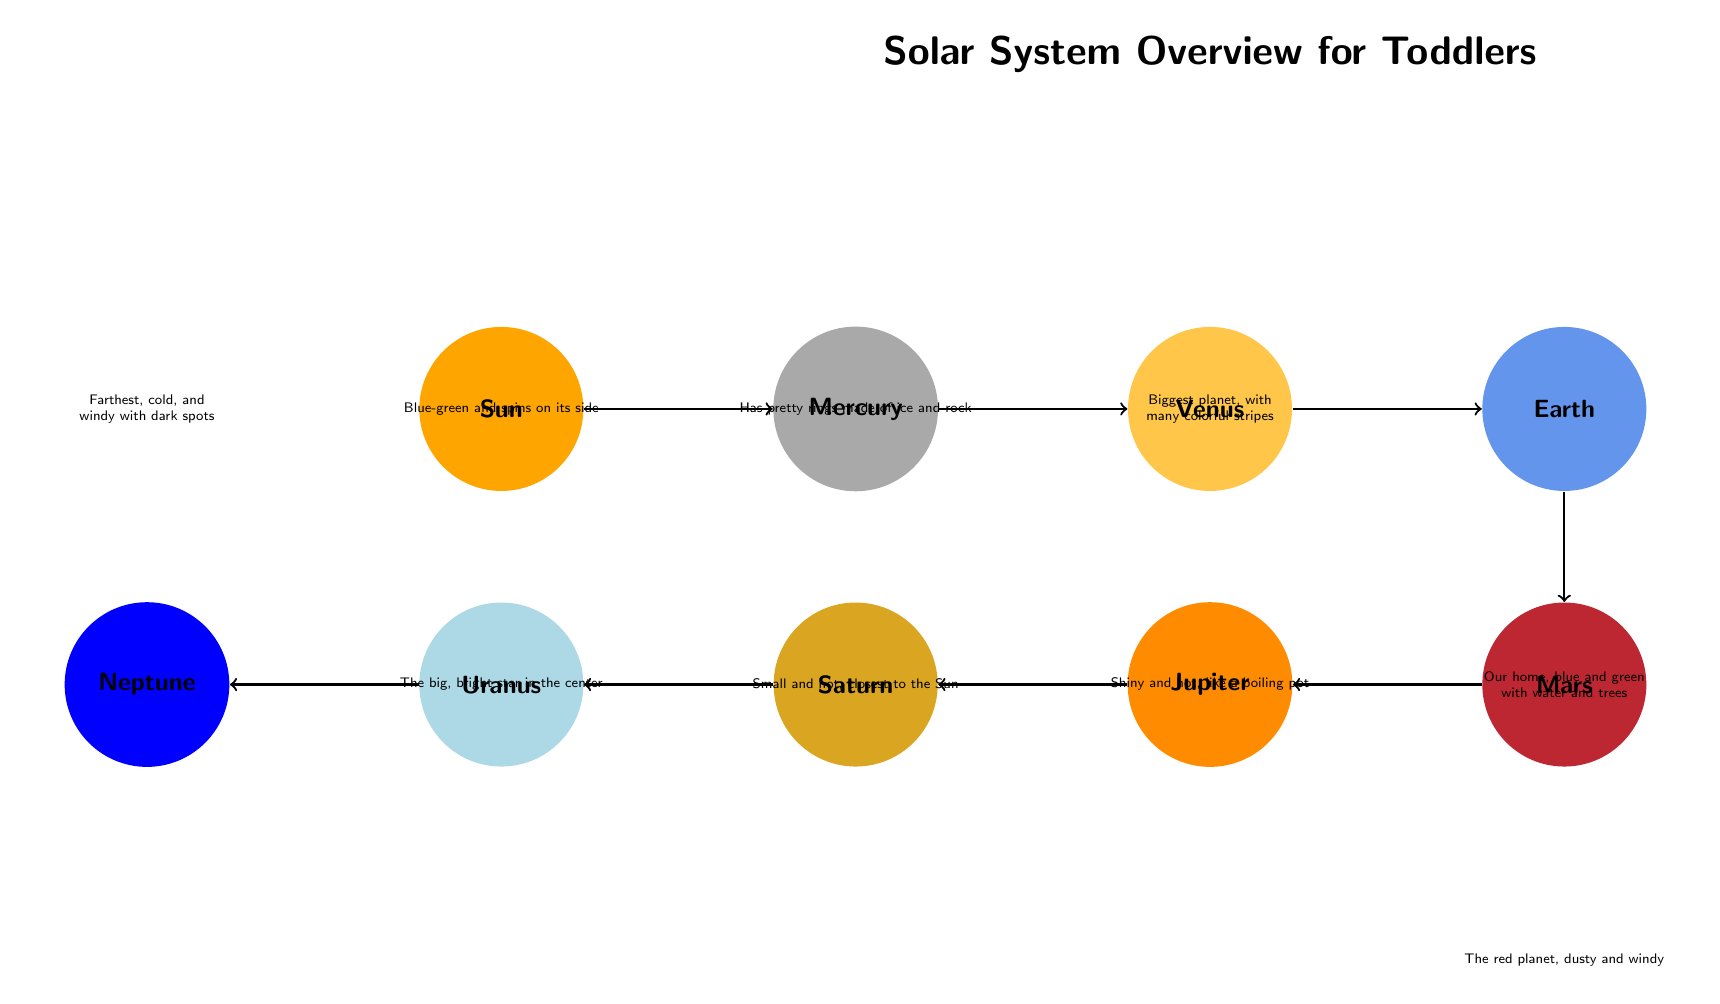What is the brightest object in the solar system? The diagram clearly identifies the Sun as the primary node, labeled prominently at the center. It depicts the Sun as a big, bright star in the center, indicating its significance among celestial bodies.
Answer: Sun Which planet is closest to the Sun? By following the arrows leading right from the Sun, you can track the planets in order. Mercury is the first one reached, marked as small and hot, which confirms its position as the closest planet.
Answer: Mercury What color is Mars depicted as? The diagram shows Mars positioned below Earth and is filled with a specific red color. Additionally, the description directly reinforces that it is the red planet.
Answer: Red How many planets are shown in the diagram? By counting the nodes that represent planets (Mercury, Venus, Earth, Mars, Jupiter, Saturn, Uranus, Neptune), which are distinctly labeled and colored, we conclude there are eight.
Answer: Eight Which planet has rings? Saturn is clearly labeled in the diagram, with a description directly stating it has pretty rings made of ice and rock, distinguishing it from other planets.
Answer: Saturn What is the relationship between Jupiter and Mars? The diagram indicates the flow of connections with arrows. From the description, Mars is mentioned under Earth, while Jupiter is shown to the left of Mars. Hence, Jupiter follows Mars in the arrangement of the planets.
Answer: Jupiter follows Mars What color is Neptune depicted as? Neptune is positioned at the far left of the diagram and is filled with a deep blue color. This color highlights its characteristics in contrast with other planets present in the overview.
Answer: Blue Which planet is described as blue-green and spins on its side? Uranus is specified in the diagram with the description of its color as blue-green. Additionally, it mentions the unique aspect of spinning on its side, making it clearly identifiable.
Answer: Uranus Which planet is the biggest? The diagram labels Jupiter specifically as the biggest planet, and it is also associated with colorful stripes that further emphasize its size compared to others.
Answer: Jupiter 